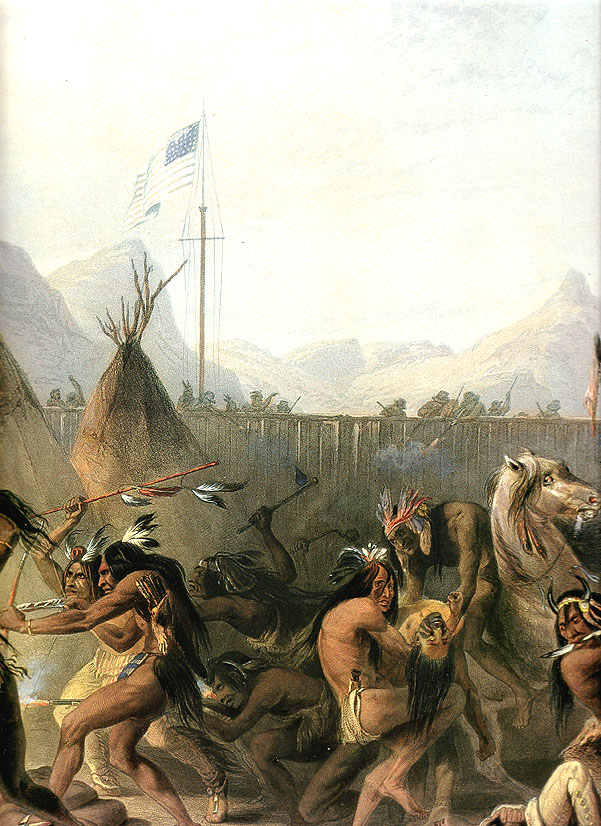What might be the historical or cultural significance of the dance depicted in this image? The dance in the image is likely a ceremonial or celebratory event, deeply rooted in Native American cultural traditions. Such dances are often spiritual in nature and serve as a means of communal expression and connection to both ancestral traditions and the land. The presence of the American flag in tandem with the dance could symbolize a complex layer of interaction between Native American tribes and the US government, possibly reflecting themes of coexistence, treaty significance, or sovereignty during a specific historical context. 